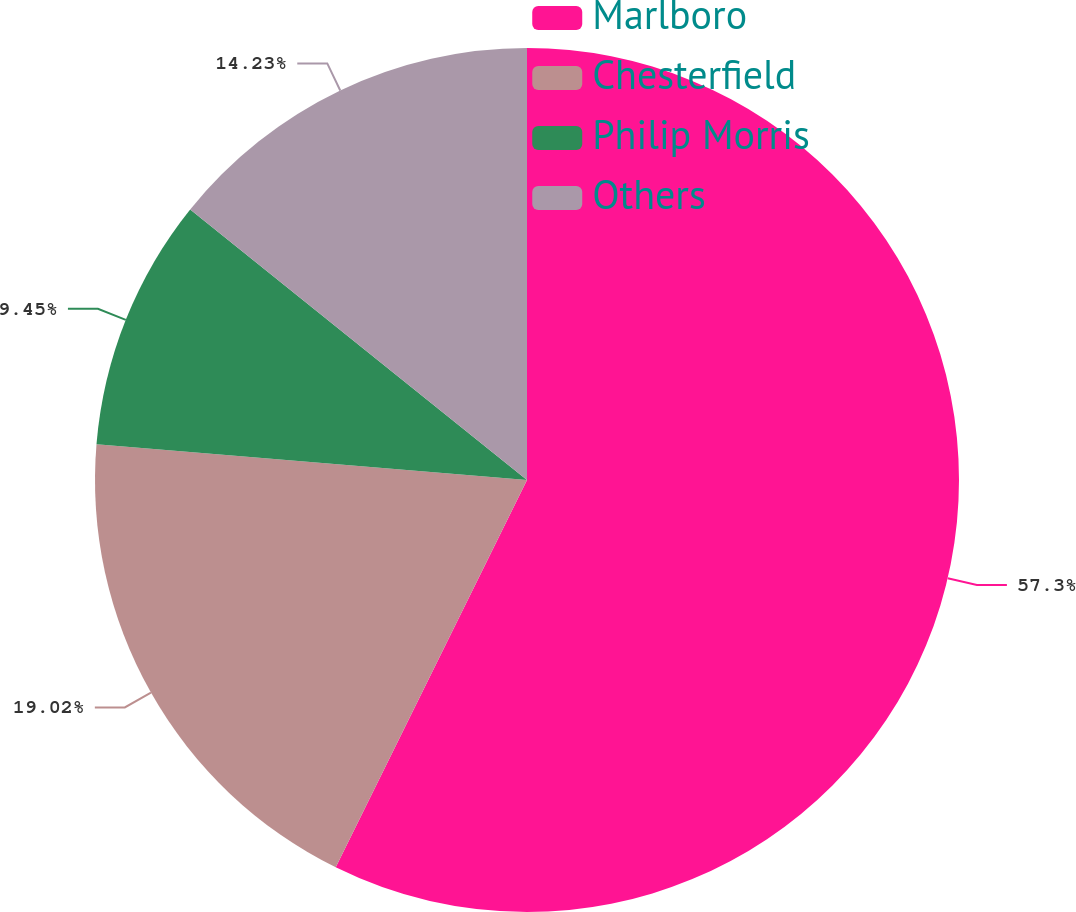Convert chart. <chart><loc_0><loc_0><loc_500><loc_500><pie_chart><fcel>Marlboro<fcel>Chesterfield<fcel>Philip Morris<fcel>Others<nl><fcel>57.3%<fcel>19.02%<fcel>9.45%<fcel>14.23%<nl></chart> 